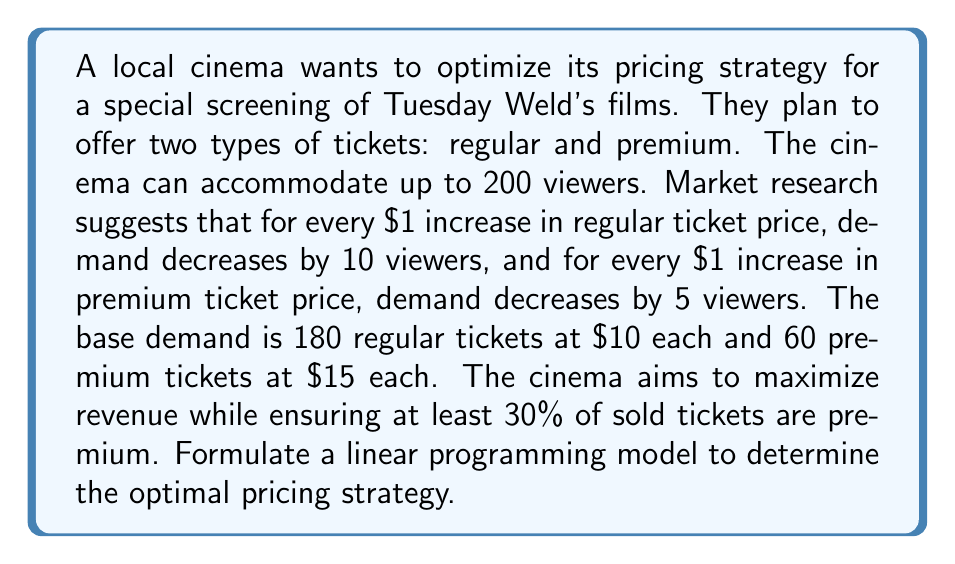Could you help me with this problem? Let's approach this step-by-step:

1) Define variables:
   $x_1$ = price of regular ticket
   $x_2$ = price of premium ticket

2) Objective function:
   Maximize revenue = (Demand for regular tickets × Price of regular ticket) + (Demand for premium tickets × Price of premium ticket)
   
   Regular demand = 180 - 10($x_1$ - 10) = 280 - 10$x_1$
   Premium demand = 60 - 5($x_2$ - 15) = 135 - 5$x_2$

   Maximize Z = (280 - 10$x_1$)$x_1$ + (135 - 5$x_2$)$x_2$

3) Constraints:
   a) Total viewers ≤ 200:
      (280 - 10$x_1$) + (135 - 5$x_2$) ≤ 200
      
   b) At least 30% premium tickets:
      (135 - 5$x_2$) ≥ 0.3[(280 - 10$x_1$) + (135 - 5$x_2$)]
      
   c) Non-negative prices:
      $x_1$ ≥ 0, $x_2$ ≥ 0

4) Final Linear Programming Model:

   Maximize Z = (280 - 10$x_1$)$x_1$ + (135 - 5$x_2$)$x_2$

   Subject to:
   415 - 10$x_1$ - 5$x_2$ ≤ 200
   -94.5 + 3$x_1$ + 3.5$x_2$ ≤ 0
   $x_1$ ≥ 0, $x_2$ ≥ 0

This linear programming model can be solved using various methods such as the simplex algorithm or graphical method to find the optimal pricing strategy.
Answer: The linear programming model to determine the optimal pricing strategy is:

Maximize Z = (280 - 10$x_1$)$x_1$ + (135 - 5$x_2$)$x_2$

Subject to:
415 - 10$x_1$ - 5$x_2$ ≤ 200
-94.5 + 3$x_1$ + 3.5$x_2$ ≤ 0
$x_1$ ≥ 0, $x_2$ ≥ 0

Where $x_1$ is the price of regular tickets and $x_2$ is the price of premium tickets. 